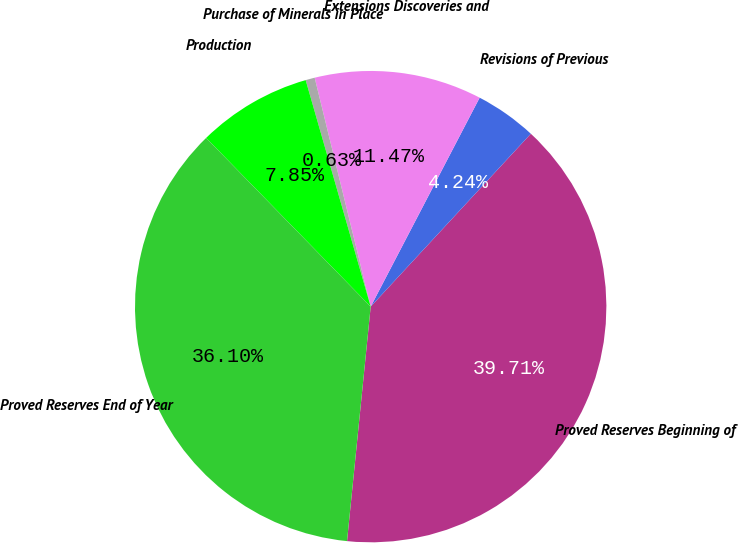Convert chart. <chart><loc_0><loc_0><loc_500><loc_500><pie_chart><fcel>Proved Reserves Beginning of<fcel>Revisions of Previous<fcel>Extensions Discoveries and<fcel>Purchase of Minerals in Place<fcel>Production<fcel>Proved Reserves End of Year<nl><fcel>39.71%<fcel>4.24%<fcel>11.47%<fcel>0.63%<fcel>7.85%<fcel>36.1%<nl></chart> 